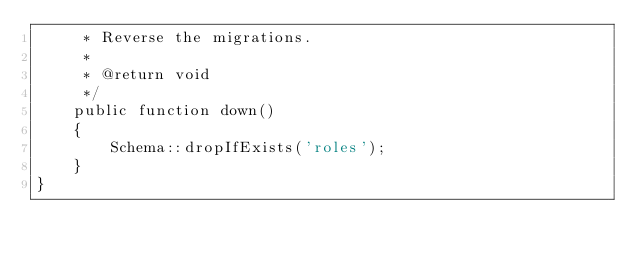<code> <loc_0><loc_0><loc_500><loc_500><_PHP_>     * Reverse the migrations.
     *
     * @return void
     */
    public function down()
    {
        Schema::dropIfExists('roles');
    }
}
</code> 